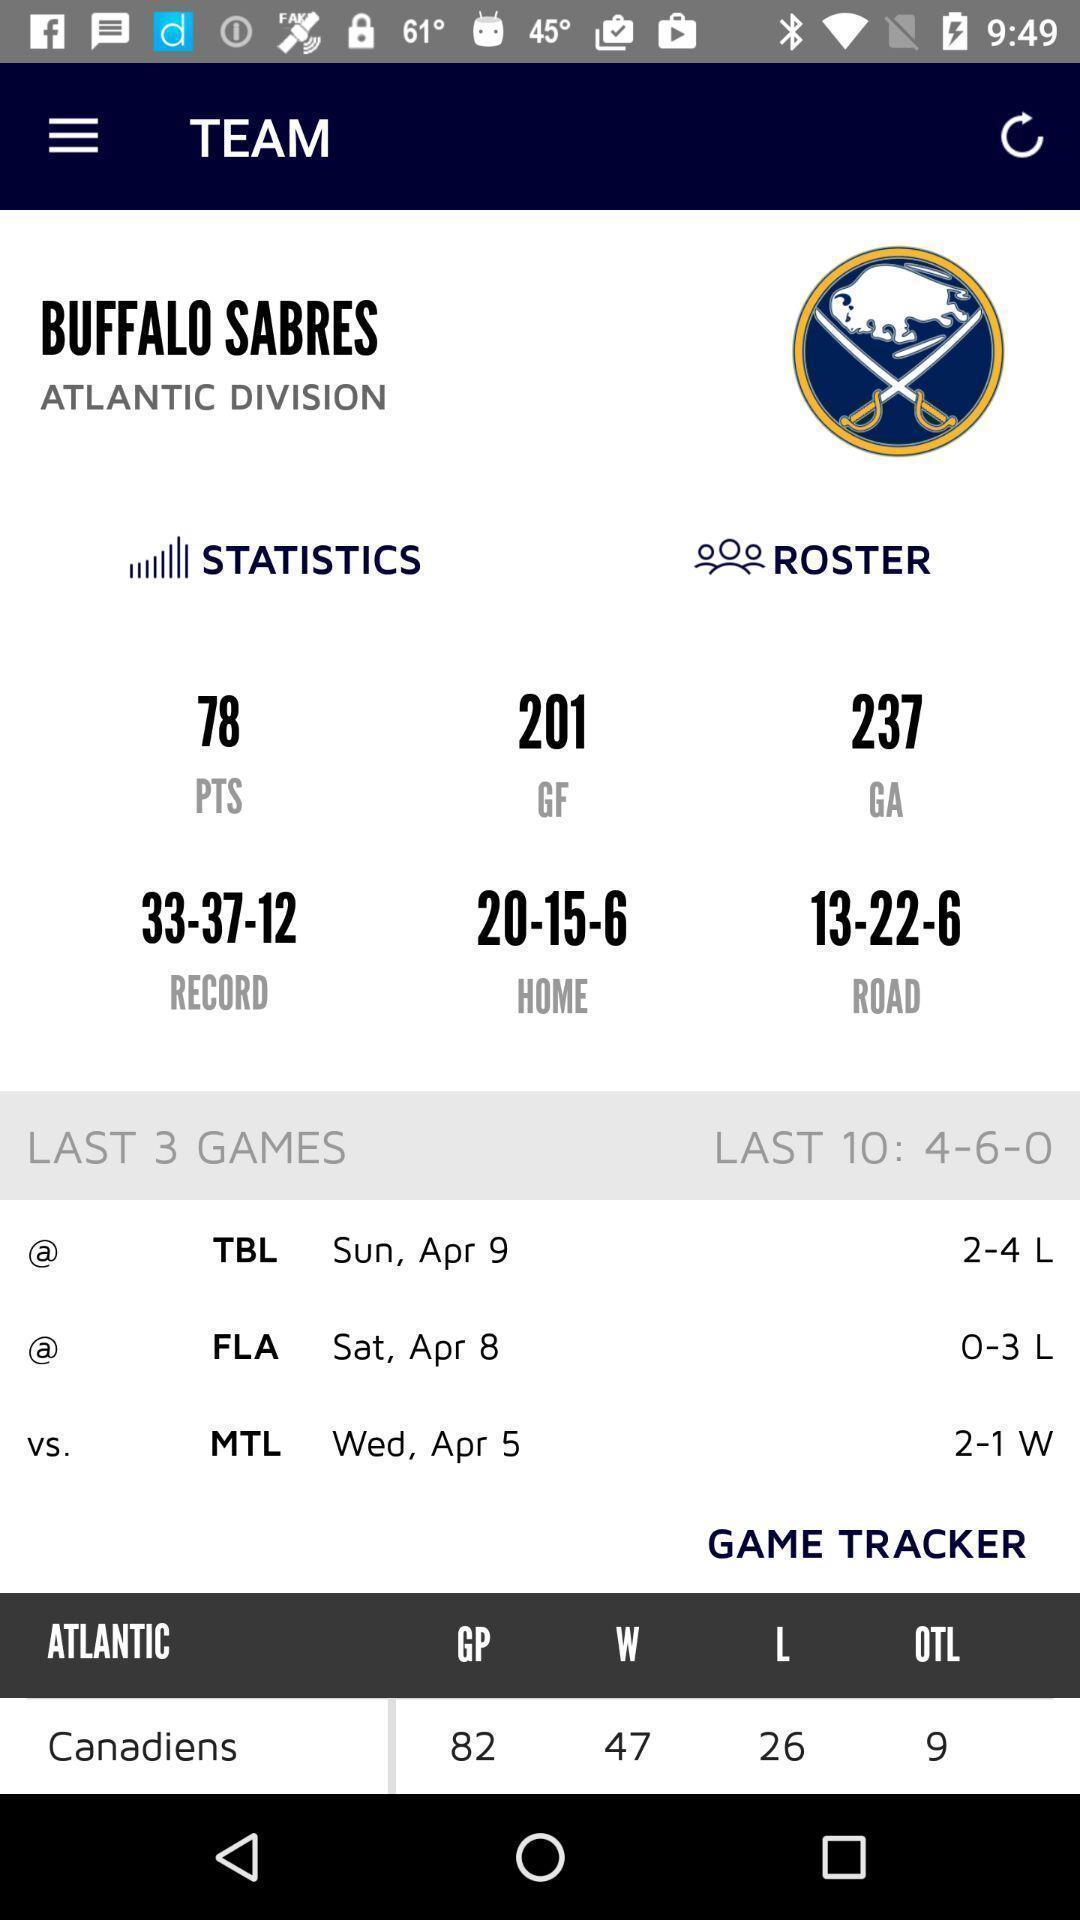Describe the content in this image. Team page in a sports app. 